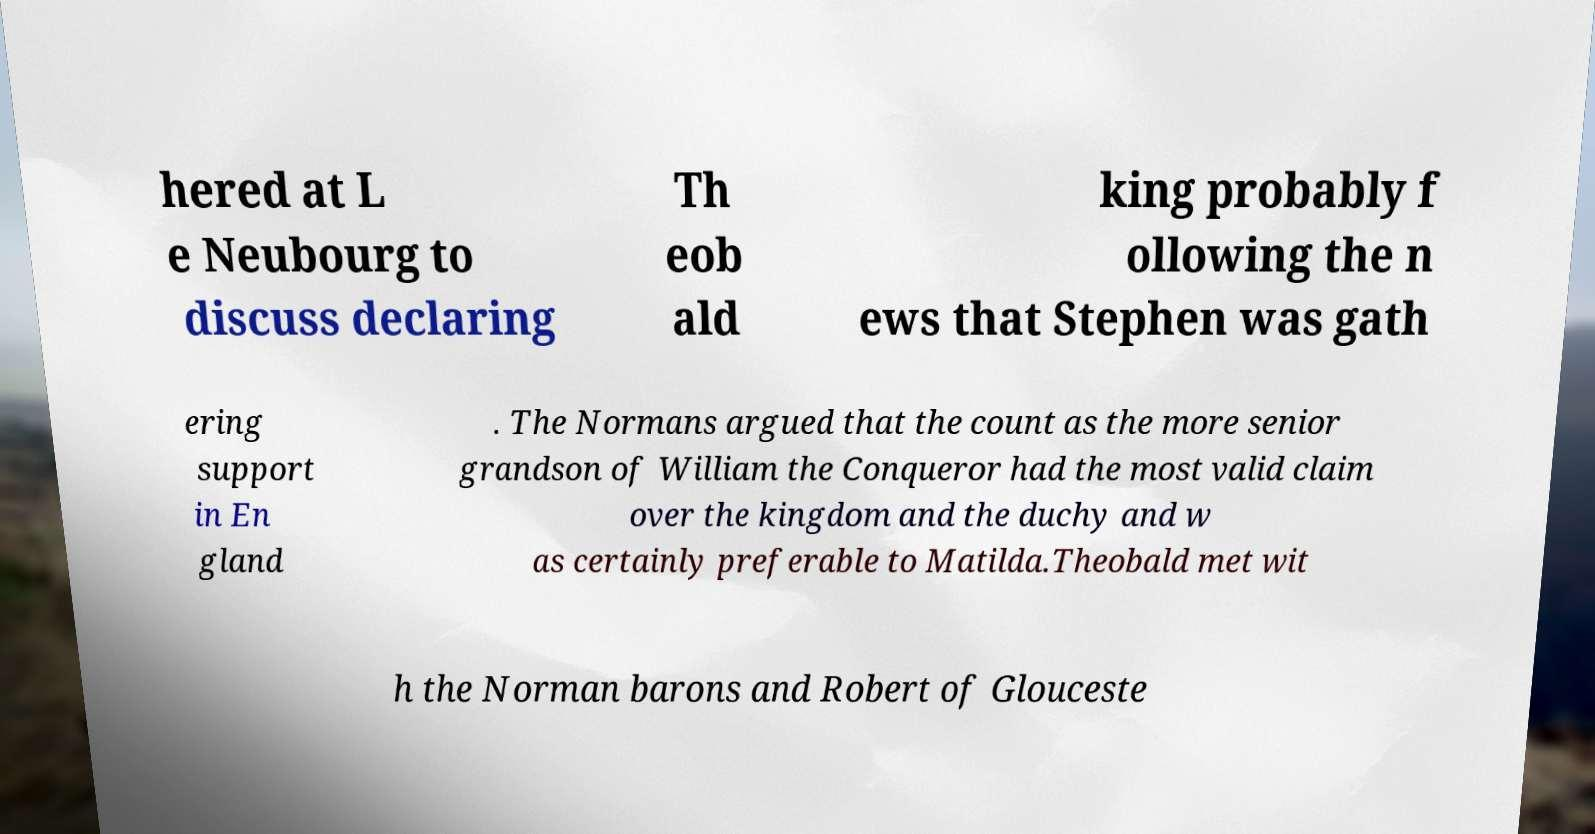Please identify and transcribe the text found in this image. hered at L e Neubourg to discuss declaring Th eob ald king probably f ollowing the n ews that Stephen was gath ering support in En gland . The Normans argued that the count as the more senior grandson of William the Conqueror had the most valid claim over the kingdom and the duchy and w as certainly preferable to Matilda.Theobald met wit h the Norman barons and Robert of Glouceste 